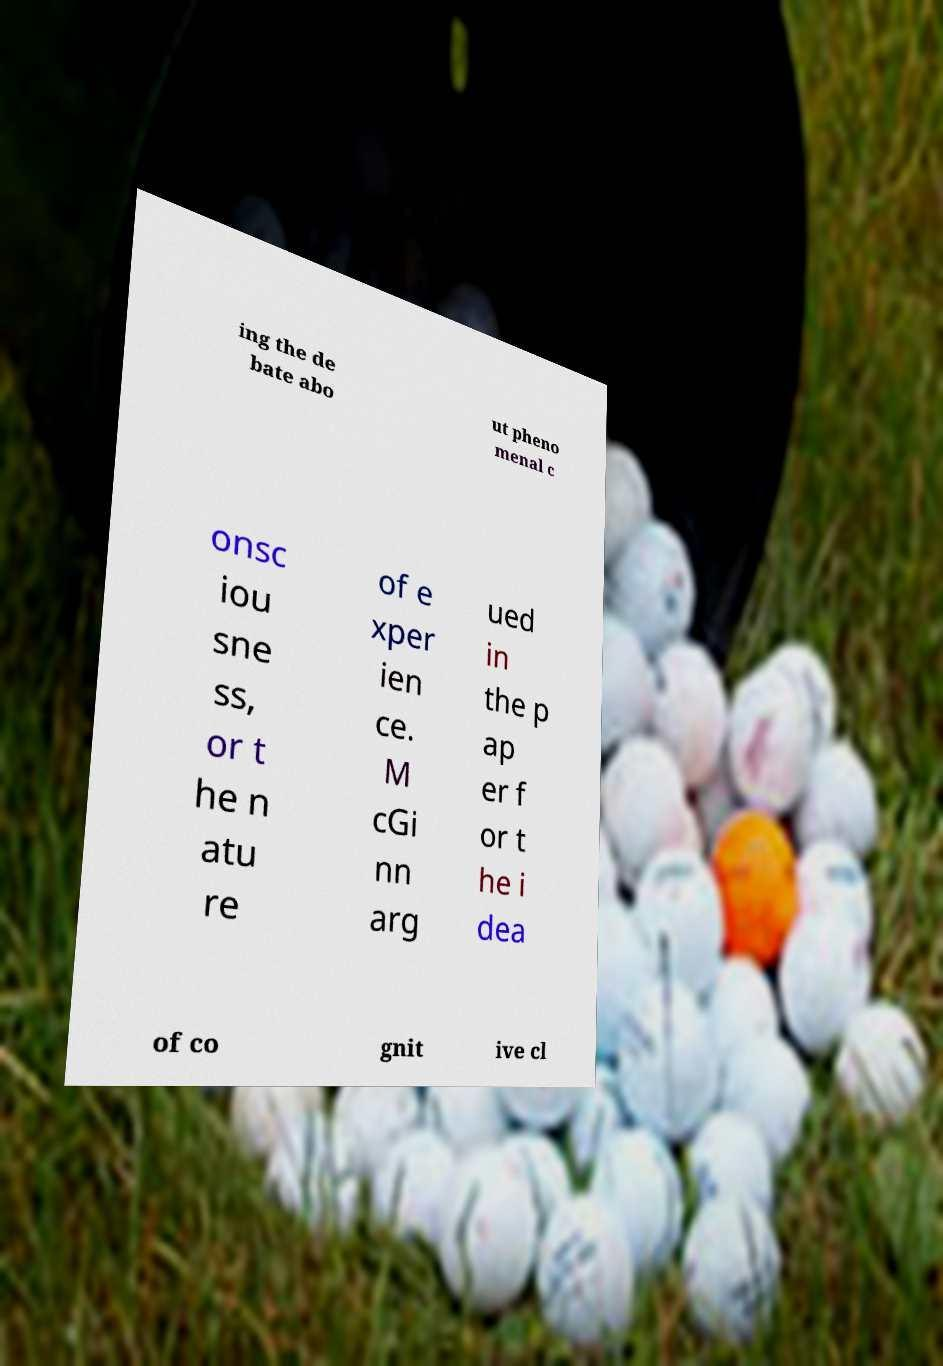There's text embedded in this image that I need extracted. Can you transcribe it verbatim? ing the de bate abo ut pheno menal c onsc iou sne ss, or t he n atu re of e xper ien ce. M cGi nn arg ued in the p ap er f or t he i dea of co gnit ive cl 